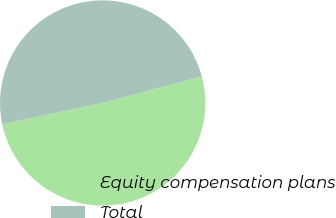<chart> <loc_0><loc_0><loc_500><loc_500><pie_chart><fcel>Equity compensation plans<fcel>Total<nl><fcel>50.85%<fcel>49.15%<nl></chart> 